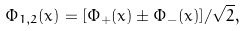<formula> <loc_0><loc_0><loc_500><loc_500>\Phi _ { 1 , 2 } ( x ) = [ \Phi _ { + } ( x ) \pm \Phi _ { - } ( x ) ] / \sqrt { 2 } ,</formula> 